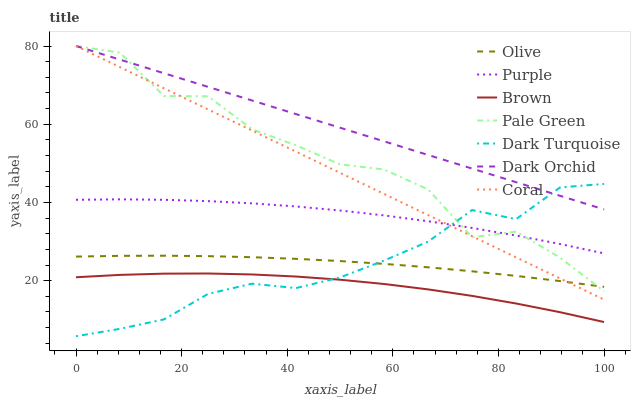Does Brown have the minimum area under the curve?
Answer yes or no. Yes. Does Dark Orchid have the maximum area under the curve?
Answer yes or no. Yes. Does Purple have the minimum area under the curve?
Answer yes or no. No. Does Purple have the maximum area under the curve?
Answer yes or no. No. Is Coral the smoothest?
Answer yes or no. Yes. Is Pale Green the roughest?
Answer yes or no. Yes. Is Purple the smoothest?
Answer yes or no. No. Is Purple the roughest?
Answer yes or no. No. Does Dark Turquoise have the lowest value?
Answer yes or no. Yes. Does Purple have the lowest value?
Answer yes or no. No. Does Pale Green have the highest value?
Answer yes or no. Yes. Does Purple have the highest value?
Answer yes or no. No. Is Olive less than Purple?
Answer yes or no. Yes. Is Pale Green greater than Brown?
Answer yes or no. Yes. Does Coral intersect Purple?
Answer yes or no. Yes. Is Coral less than Purple?
Answer yes or no. No. Is Coral greater than Purple?
Answer yes or no. No. Does Olive intersect Purple?
Answer yes or no. No. 